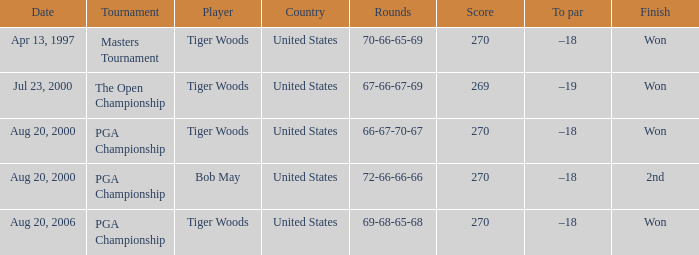What players finished 2nd? Bob May. 